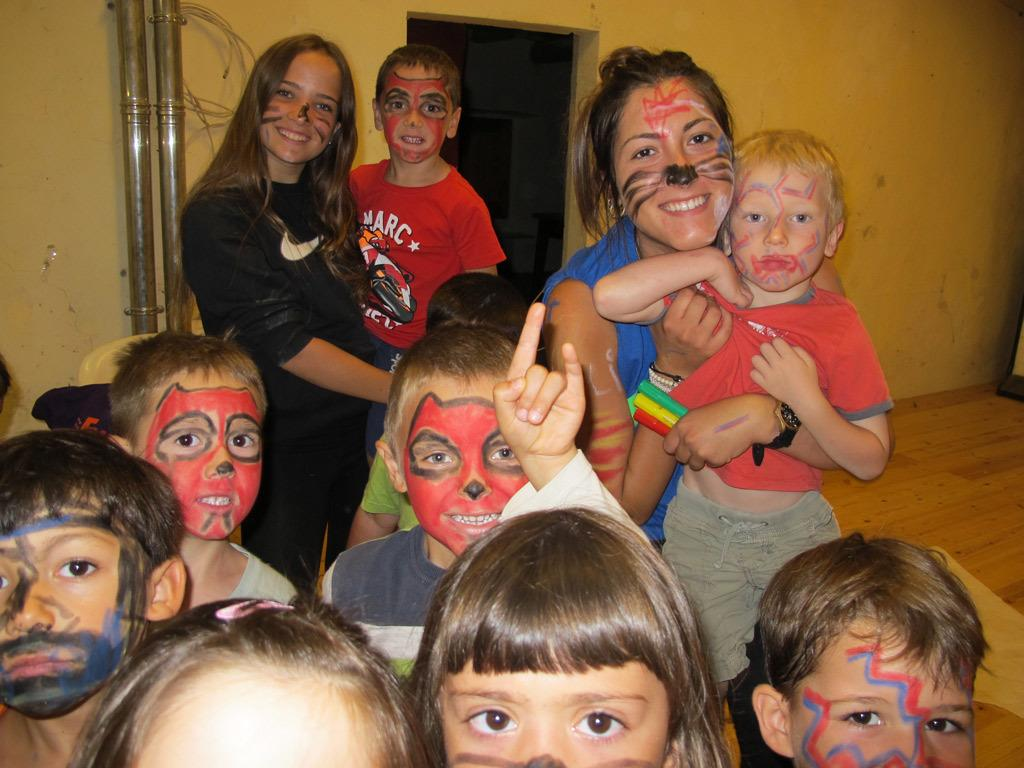Who is present in the image? There are women in the image. What are the women doing in the image? The women are standing near children. What object can be seen in the image? There is a pipe visible in the image. What architectural feature is present in the image? There is a door in the image. What type of connection can be seen in the image? There is no connection present in the image; it features women standing near children, a pipe, and a door. Can you describe the yard in the image? There is no yard present in the image; it is an indoor setting with a door and a pipe. 